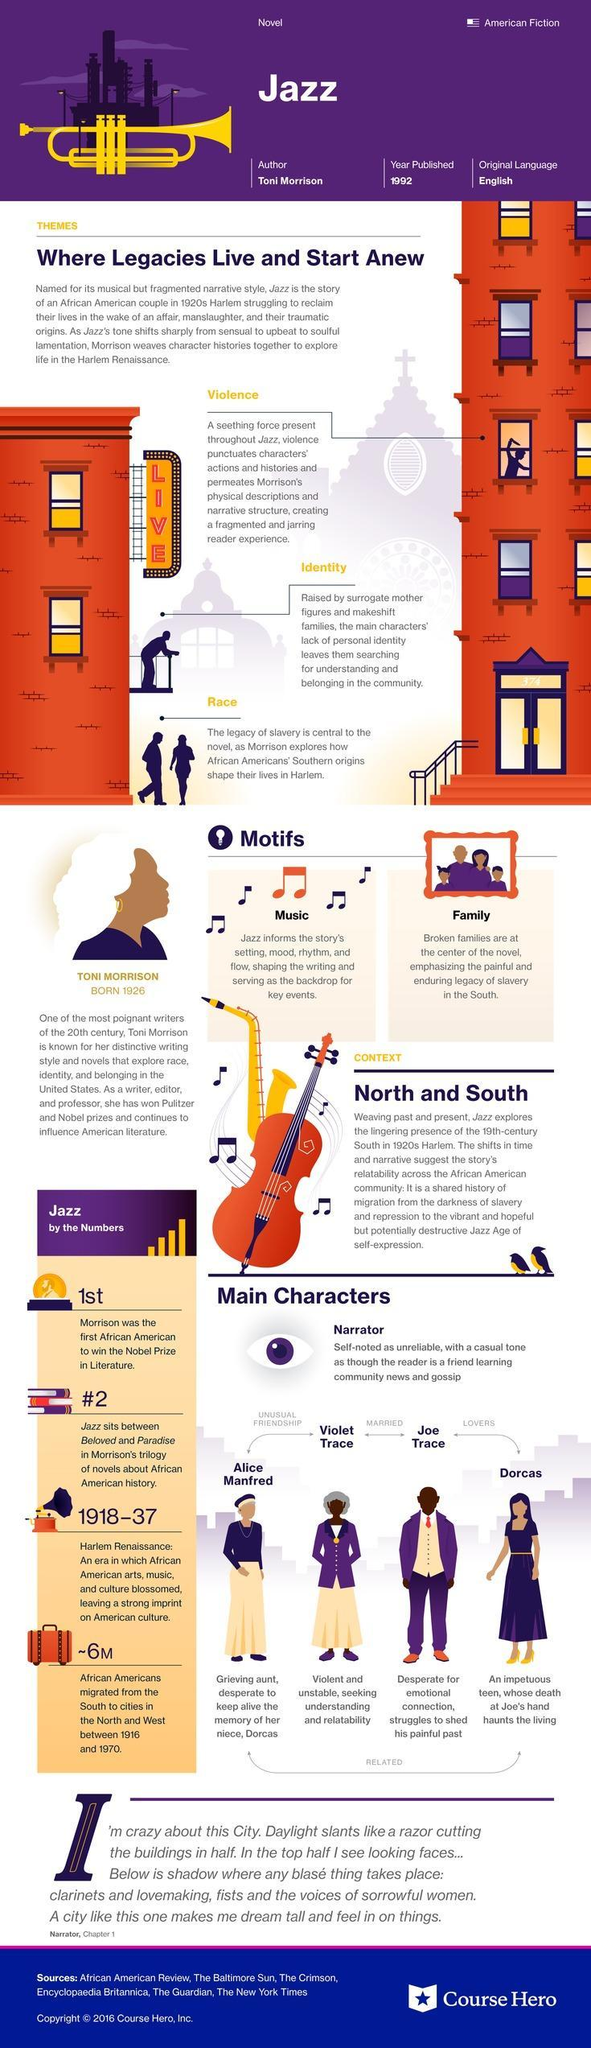who is the lover of Dorcas in the novel Jazz?
Answer the question with a short phrase. Joe Trace what are the themes of the novel Jazz? violence, identity, race who is the husband of Violet Trace in the novel Jazz? Joe Trace 